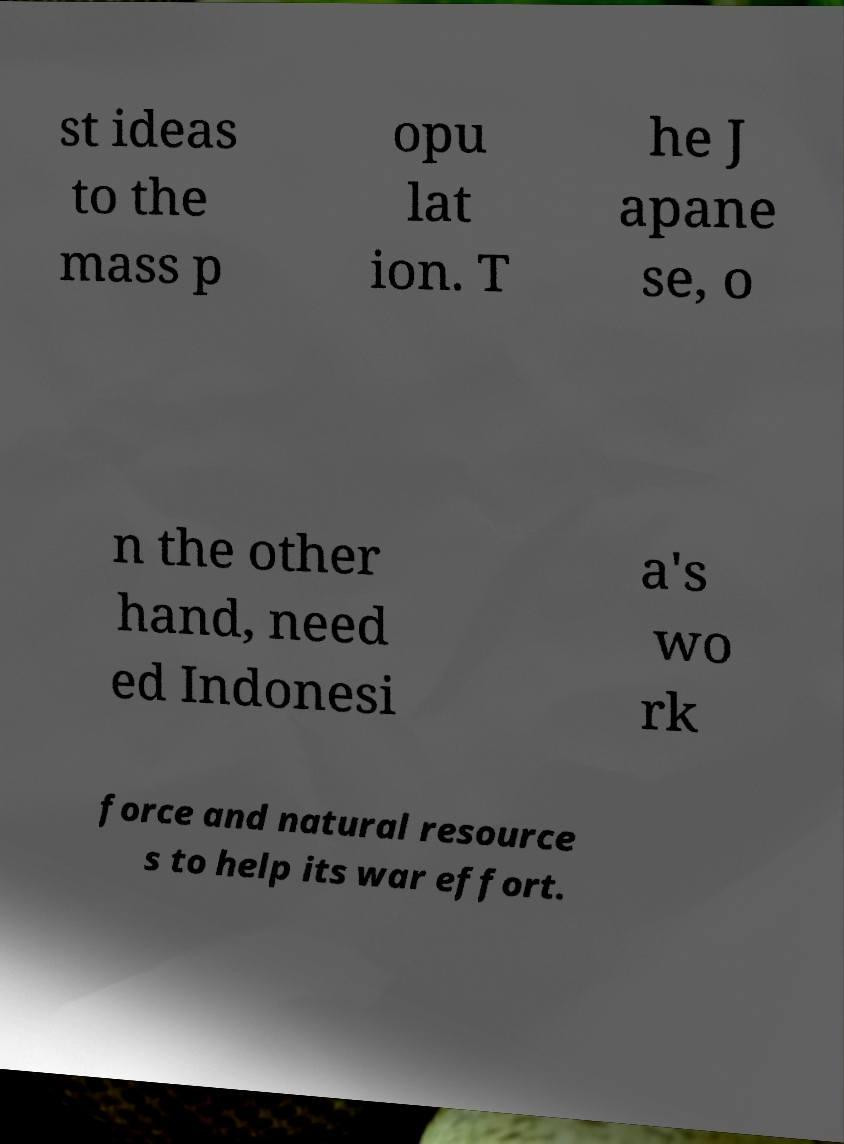Could you assist in decoding the text presented in this image and type it out clearly? st ideas to the mass p opu lat ion. T he J apane se, o n the other hand, need ed Indonesi a's wo rk force and natural resource s to help its war effort. 